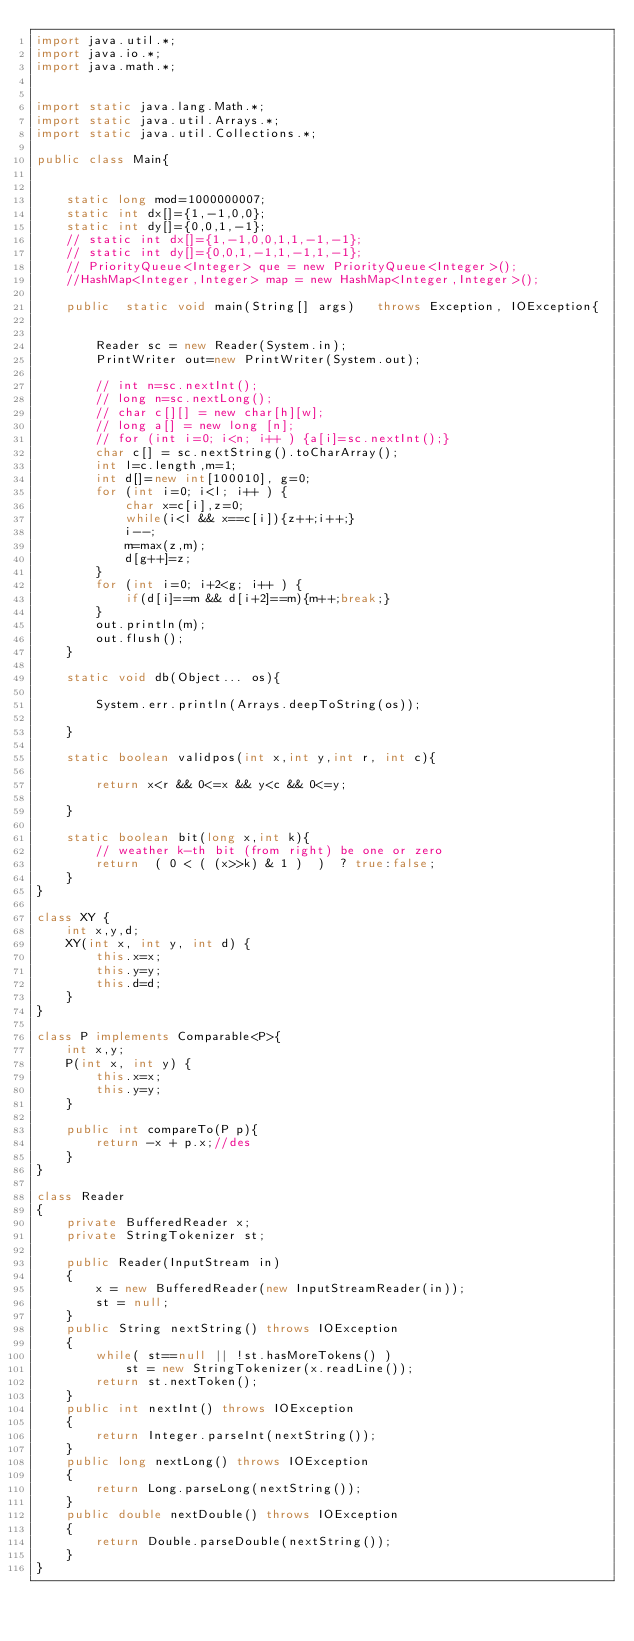Convert code to text. <code><loc_0><loc_0><loc_500><loc_500><_Java_>import java.util.*;
import java.io.*;
import java.math.*;
 
 
import static java.lang.Math.*;
import static java.util.Arrays.*;
import static java.util.Collections.*;
 
public class Main{ 
 
 
    static long mod=1000000007;
    static int dx[]={1,-1,0,0};
    static int dy[]={0,0,1,-1};
    // static int dx[]={1,-1,0,0,1,1,-1,-1};
    // static int dy[]={0,0,1,-1,1,-1,1,-1};
    // PriorityQueue<Integer> que = new PriorityQueue<Integer>(); 
    //HashMap<Integer,Integer> map = new HashMap<Integer,Integer>();
 
    public  static void main(String[] args)   throws Exception, IOException{
     
        
        Reader sc = new Reader(System.in);
        PrintWriter out=new PrintWriter(System.out);
     
        // int n=sc.nextInt();
        // long n=sc.nextLong();
        // char c[][] = new char[h][w];
        // long a[] = new long [n];
        // for (int i=0; i<n; i++ ) {a[i]=sc.nextInt();}
        char c[] = sc.nextString().toCharArray();
        int l=c.length,m=1;
        int d[]=new int[100010], g=0;
        for (int i=0; i<l; i++ ) {
            char x=c[i],z=0;
            while(i<l && x==c[i]){z++;i++;}
            i--;
            m=max(z,m);
            d[g++]=z;
        }
        for (int i=0; i+2<g; i++ ) {
            if(d[i]==m && d[i+2]==m){m++;break;}
        }
        out.println(m);
        out.flush();
    }

    static void db(Object... os){
     
        System.err.println(Arrays.deepToString(os));
     
    }
     
    static boolean validpos(int x,int y,int r, int c){
        
        return x<r && 0<=x && y<c && 0<=y;
        
    }
     
    static boolean bit(long x,int k){
        // weather k-th bit (from right) be one or zero
        return  ( 0 < ( (x>>k) & 1 )  )  ? true:false;
    }    
}

class XY {
    int x,y,d;
    XY(int x, int y, int d) {
        this.x=x;
        this.y=y;
        this.d=d;
    } 
}
 
class P implements Comparable<P>{
    int x,y;
    P(int x, int y) {
        this.x=x;
        this.y=y;
    } 
      
    public int compareTo(P p){
        return -x + p.x;//des
    } 
}
 
class Reader
{ 
    private BufferedReader x;
    private StringTokenizer st;
    
    public Reader(InputStream in)
    {
        x = new BufferedReader(new InputStreamReader(in));
        st = null;
    }
    public String nextString() throws IOException
    {
        while( st==null || !st.hasMoreTokens() )
            st = new StringTokenizer(x.readLine());
        return st.nextToken();
    }
    public int nextInt() throws IOException
    {
        return Integer.parseInt(nextString());
    }
    public long nextLong() throws IOException
    {
        return Long.parseLong(nextString());
    }
    public double nextDouble() throws IOException
    {
        return Double.parseDouble(nextString());
    }
}</code> 